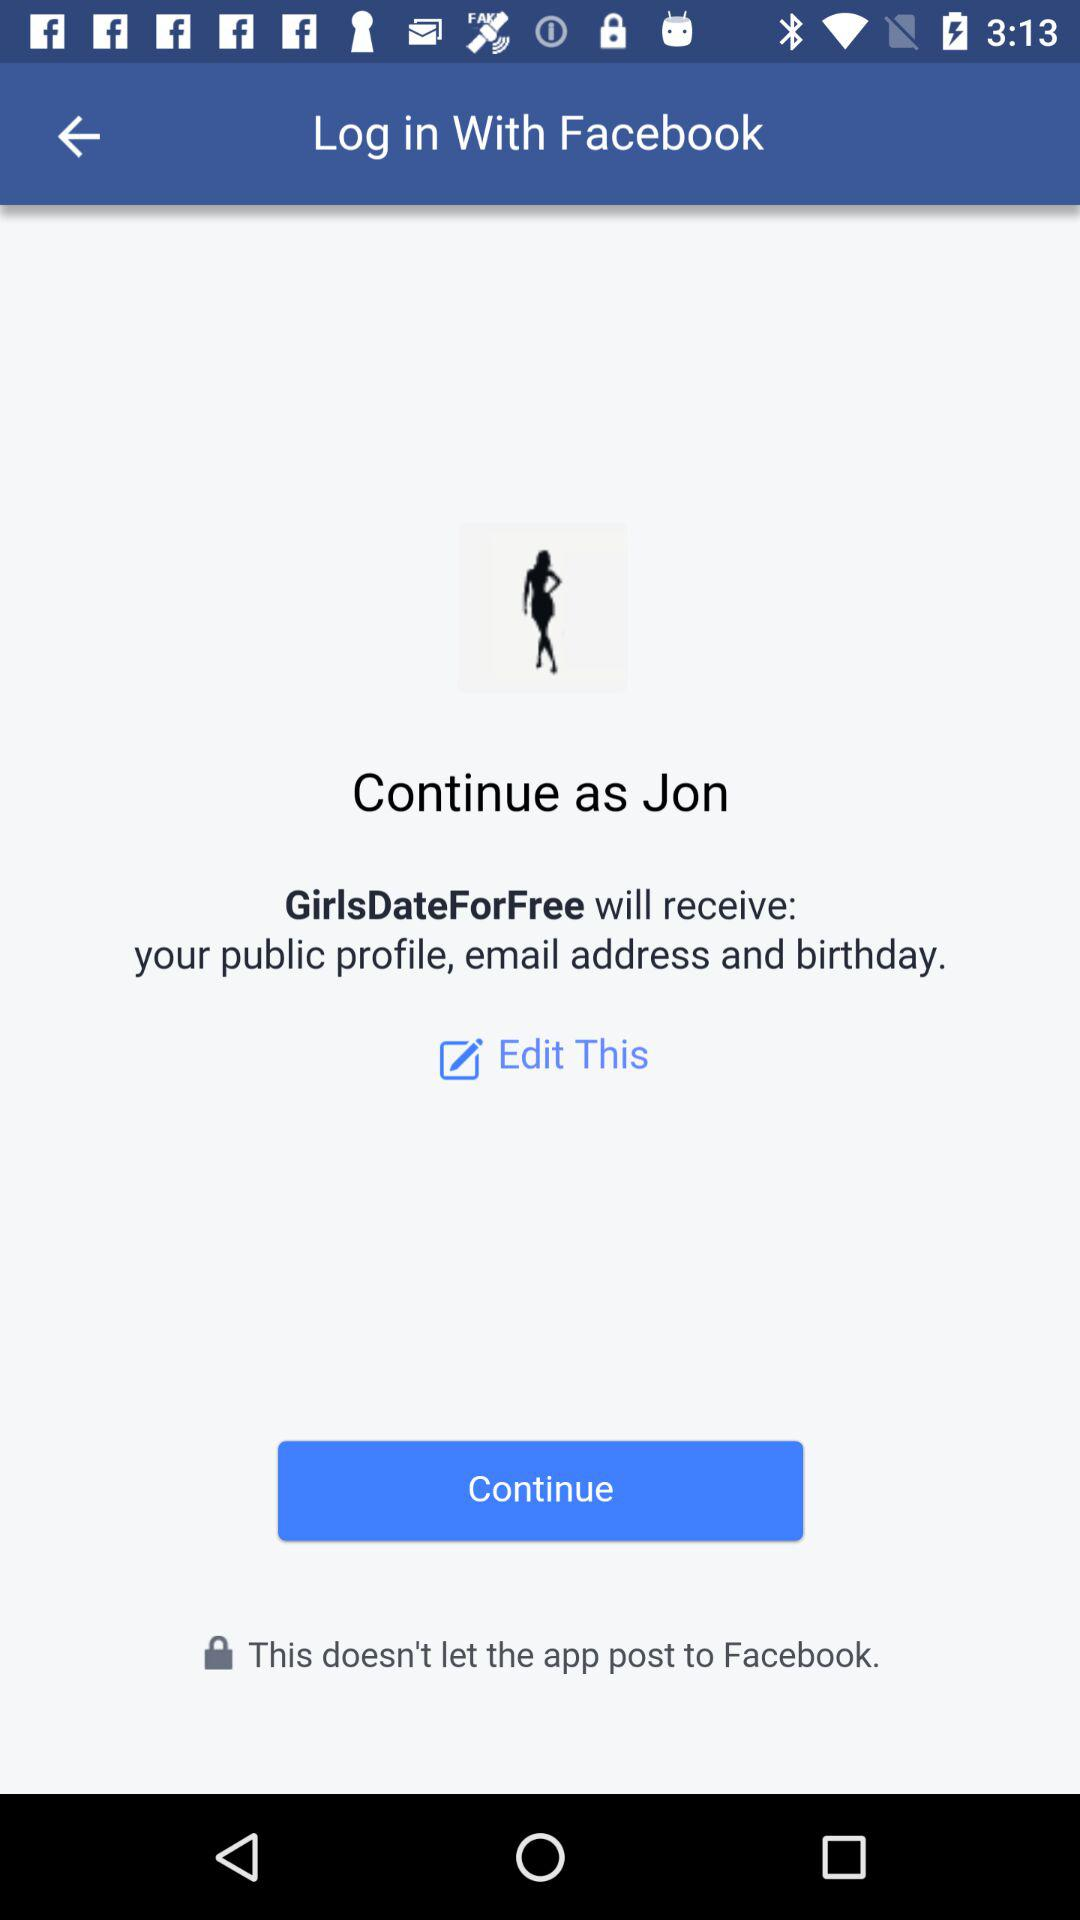Through which application can we log in? You can log in through "Facebook". 